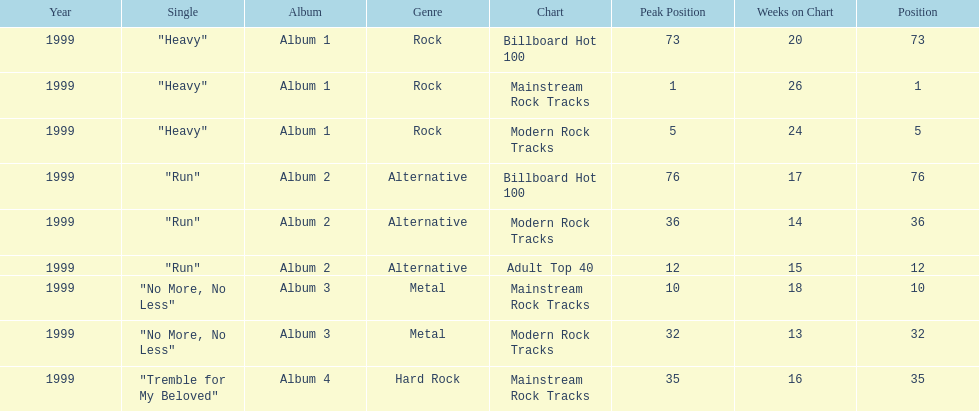Parse the full table. {'header': ['Year', 'Single', 'Album', 'Genre', 'Chart', 'Peak Position', 'Weeks on Chart', 'Position'], 'rows': [['1999', '"Heavy"', 'Album 1', 'Rock', 'Billboard Hot 100', '73', '20', '73'], ['1999', '"Heavy"', 'Album 1', 'Rock', 'Mainstream Rock Tracks', '1', '26', '1'], ['1999', '"Heavy"', 'Album 1', 'Rock', 'Modern Rock Tracks', '5', '24', '5'], ['1999', '"Run"', 'Album 2', 'Alternative', 'Billboard Hot 100', '76', '17', '76'], ['1999', '"Run"', 'Album 2', 'Alternative', 'Modern Rock Tracks', '36', '14', '36'], ['1999', '"Run"', 'Album 2', 'Alternative', 'Adult Top 40', '12', '15', '12'], ['1999', '"No More, No Less"', 'Album 3', 'Metal', 'Mainstream Rock Tracks', '10', '18', '10'], ['1999', '"No More, No Less"', 'Album 3', 'Metal', 'Modern Rock Tracks', '32', '13', '32'], ['1999', '"Tremble for My Beloved"', 'Album 4', 'Hard Rock', 'Mainstream Rock Tracks', '35', '16', '35']]} How many different charts did "run" make? 3. 